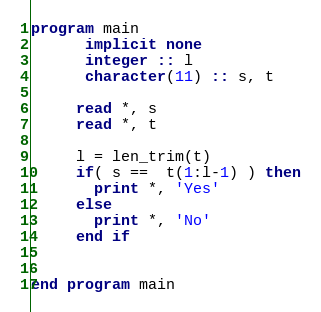<code> <loc_0><loc_0><loc_500><loc_500><_FORTRAN_>program main
      implicit none
      integer :: l 
      character(11) :: s, t

     read *, s
     read *, t
     
     l = len_trim(t)
     if( s ==  t(1:l-1) ) then
       print *, 'Yes'
     else
       print *, 'No'
     end if

      
end program main
</code> 